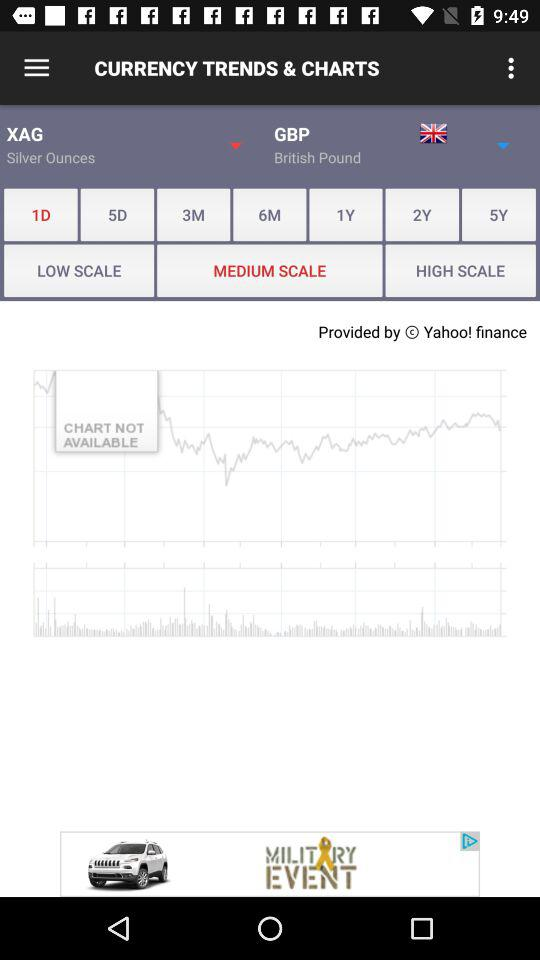How many days have been selected? The number of selected days is 1. 